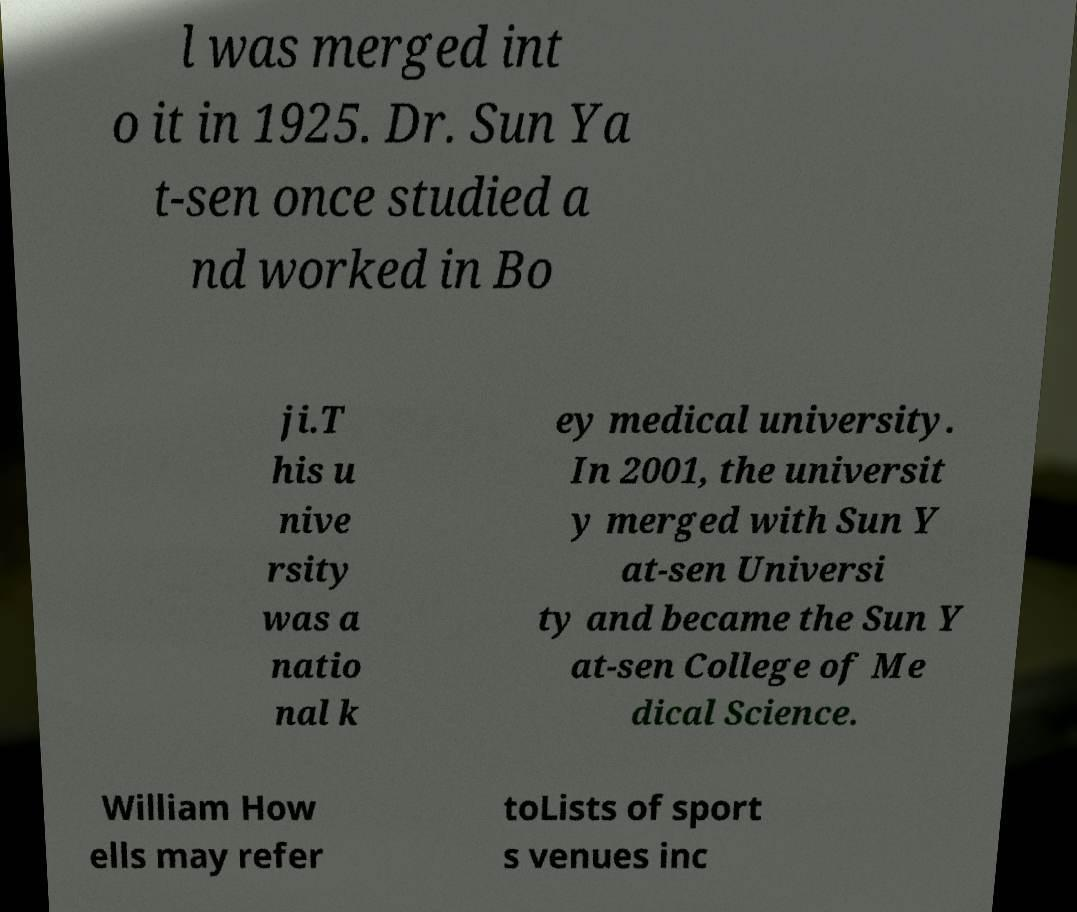For documentation purposes, I need the text within this image transcribed. Could you provide that? l was merged int o it in 1925. Dr. Sun Ya t-sen once studied a nd worked in Bo ji.T his u nive rsity was a natio nal k ey medical university. In 2001, the universit y merged with Sun Y at-sen Universi ty and became the Sun Y at-sen College of Me dical Science. William How ells may refer toLists of sport s venues inc 